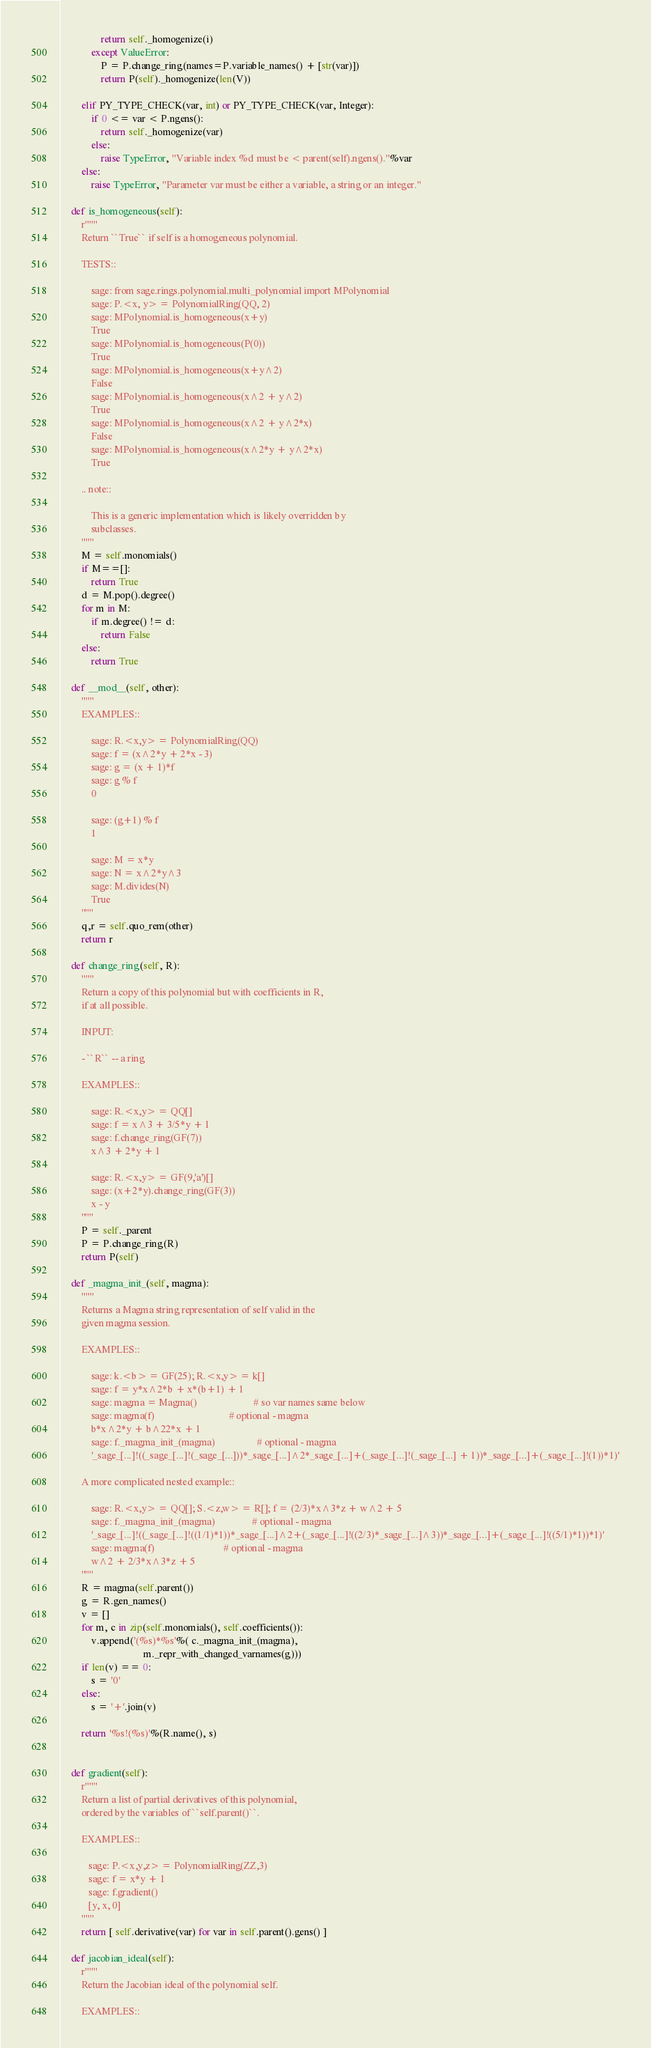Convert code to text. <code><loc_0><loc_0><loc_500><loc_500><_Cython_>                return self._homogenize(i)
            except ValueError:
                P = P.change_ring(names=P.variable_names() + [str(var)])
                return P(self)._homogenize(len(V))

        elif PY_TYPE_CHECK(var, int) or PY_TYPE_CHECK(var, Integer):
            if 0 <= var < P.ngens():
                return self._homogenize(var)
            else:
                raise TypeError, "Variable index %d must be < parent(self).ngens()."%var
        else:
            raise TypeError, "Parameter var must be either a variable, a string or an integer."

    def is_homogeneous(self):
        r"""
        Return ``True`` if self is a homogeneous polynomial.

        TESTS::

            sage: from sage.rings.polynomial.multi_polynomial import MPolynomial
            sage: P.<x, y> = PolynomialRing(QQ, 2)
            sage: MPolynomial.is_homogeneous(x+y)
            True
            sage: MPolynomial.is_homogeneous(P(0))
            True
            sage: MPolynomial.is_homogeneous(x+y^2)
            False
            sage: MPolynomial.is_homogeneous(x^2 + y^2)
            True
            sage: MPolynomial.is_homogeneous(x^2 + y^2*x)
            False
            sage: MPolynomial.is_homogeneous(x^2*y + y^2*x)
            True

        .. note::

            This is a generic implementation which is likely overridden by
            subclasses.
        """
        M = self.monomials()
        if M==[]:
            return True
        d = M.pop().degree()
        for m in M:
            if m.degree() != d:
                return False
        else:
            return True

    def __mod__(self, other):
        """
        EXAMPLES::

            sage: R.<x,y> = PolynomialRing(QQ)
            sage: f = (x^2*y + 2*x - 3)
            sage: g = (x + 1)*f
            sage: g % f
            0

            sage: (g+1) % f
            1

            sage: M = x*y
            sage: N = x^2*y^3
            sage: M.divides(N)
            True
        """
        q,r = self.quo_rem(other)
        return r

    def change_ring(self, R):
        """
        Return a copy of this polynomial but with coefficients in R,
        if at all possible.

        INPUT:

        - ``R`` -- a ring

        EXAMPLES::

            sage: R.<x,y> = QQ[]
            sage: f = x^3 + 3/5*y + 1
            sage: f.change_ring(GF(7))
            x^3 + 2*y + 1

            sage: R.<x,y> = GF(9,'a')[]
            sage: (x+2*y).change_ring(GF(3))
            x - y
        """
        P = self._parent
        P = P.change_ring(R)
        return P(self)

    def _magma_init_(self, magma):
        """
        Returns a Magma string representation of self valid in the
        given magma session.

        EXAMPLES::

            sage: k.<b> = GF(25); R.<x,y> = k[]
            sage: f = y*x^2*b + x*(b+1) + 1
            sage: magma = Magma()                       # so var names same below
            sage: magma(f)                              # optional - magma
            b*x^2*y + b^22*x + 1
            sage: f._magma_init_(magma)                 # optional - magma
            '_sage_[...]!((_sage_[...]!(_sage_[...]))*_sage_[...]^2*_sage_[...]+(_sage_[...]!(_sage_[...] + 1))*_sage_[...]+(_sage_[...]!(1))*1)'

        A more complicated nested example::

            sage: R.<x,y> = QQ[]; S.<z,w> = R[]; f = (2/3)*x^3*z + w^2 + 5
            sage: f._magma_init_(magma)               # optional - magma
            '_sage_[...]!((_sage_[...]!((1/1)*1))*_sage_[...]^2+(_sage_[...]!((2/3)*_sage_[...]^3))*_sage_[...]+(_sage_[...]!((5/1)*1))*1)'
            sage: magma(f)                            # optional - magma
            w^2 + 2/3*x^3*z + 5
        """
        R = magma(self.parent())
        g = R.gen_names()
        v = []
        for m, c in zip(self.monomials(), self.coefficients()):
            v.append('(%s)*%s'%( c._magma_init_(magma),
                                 m._repr_with_changed_varnames(g)))
        if len(v) == 0:
            s = '0'
        else:
            s = '+'.join(v)

        return '%s!(%s)'%(R.name(), s)


    def gradient(self):
        r"""
        Return a list of partial derivatives of this polynomial,
        ordered by the variables of ``self.parent()``.

        EXAMPLES::

           sage: P.<x,y,z> = PolynomialRing(ZZ,3)
           sage: f = x*y + 1
           sage: f.gradient()
           [y, x, 0]
        """
        return [ self.derivative(var) for var in self.parent().gens() ]

    def jacobian_ideal(self):
        r"""
        Return the Jacobian ideal of the polynomial self.

        EXAMPLES::
</code> 